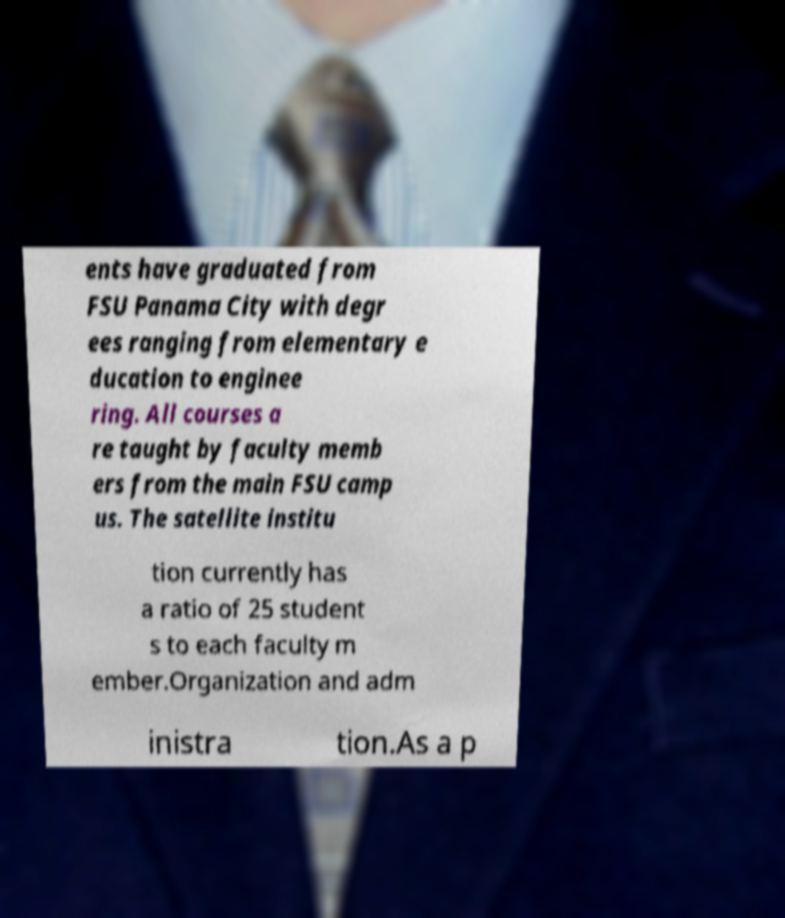Please read and relay the text visible in this image. What does it say? ents have graduated from FSU Panama City with degr ees ranging from elementary e ducation to enginee ring. All courses a re taught by faculty memb ers from the main FSU camp us. The satellite institu tion currently has a ratio of 25 student s to each faculty m ember.Organization and adm inistra tion.As a p 